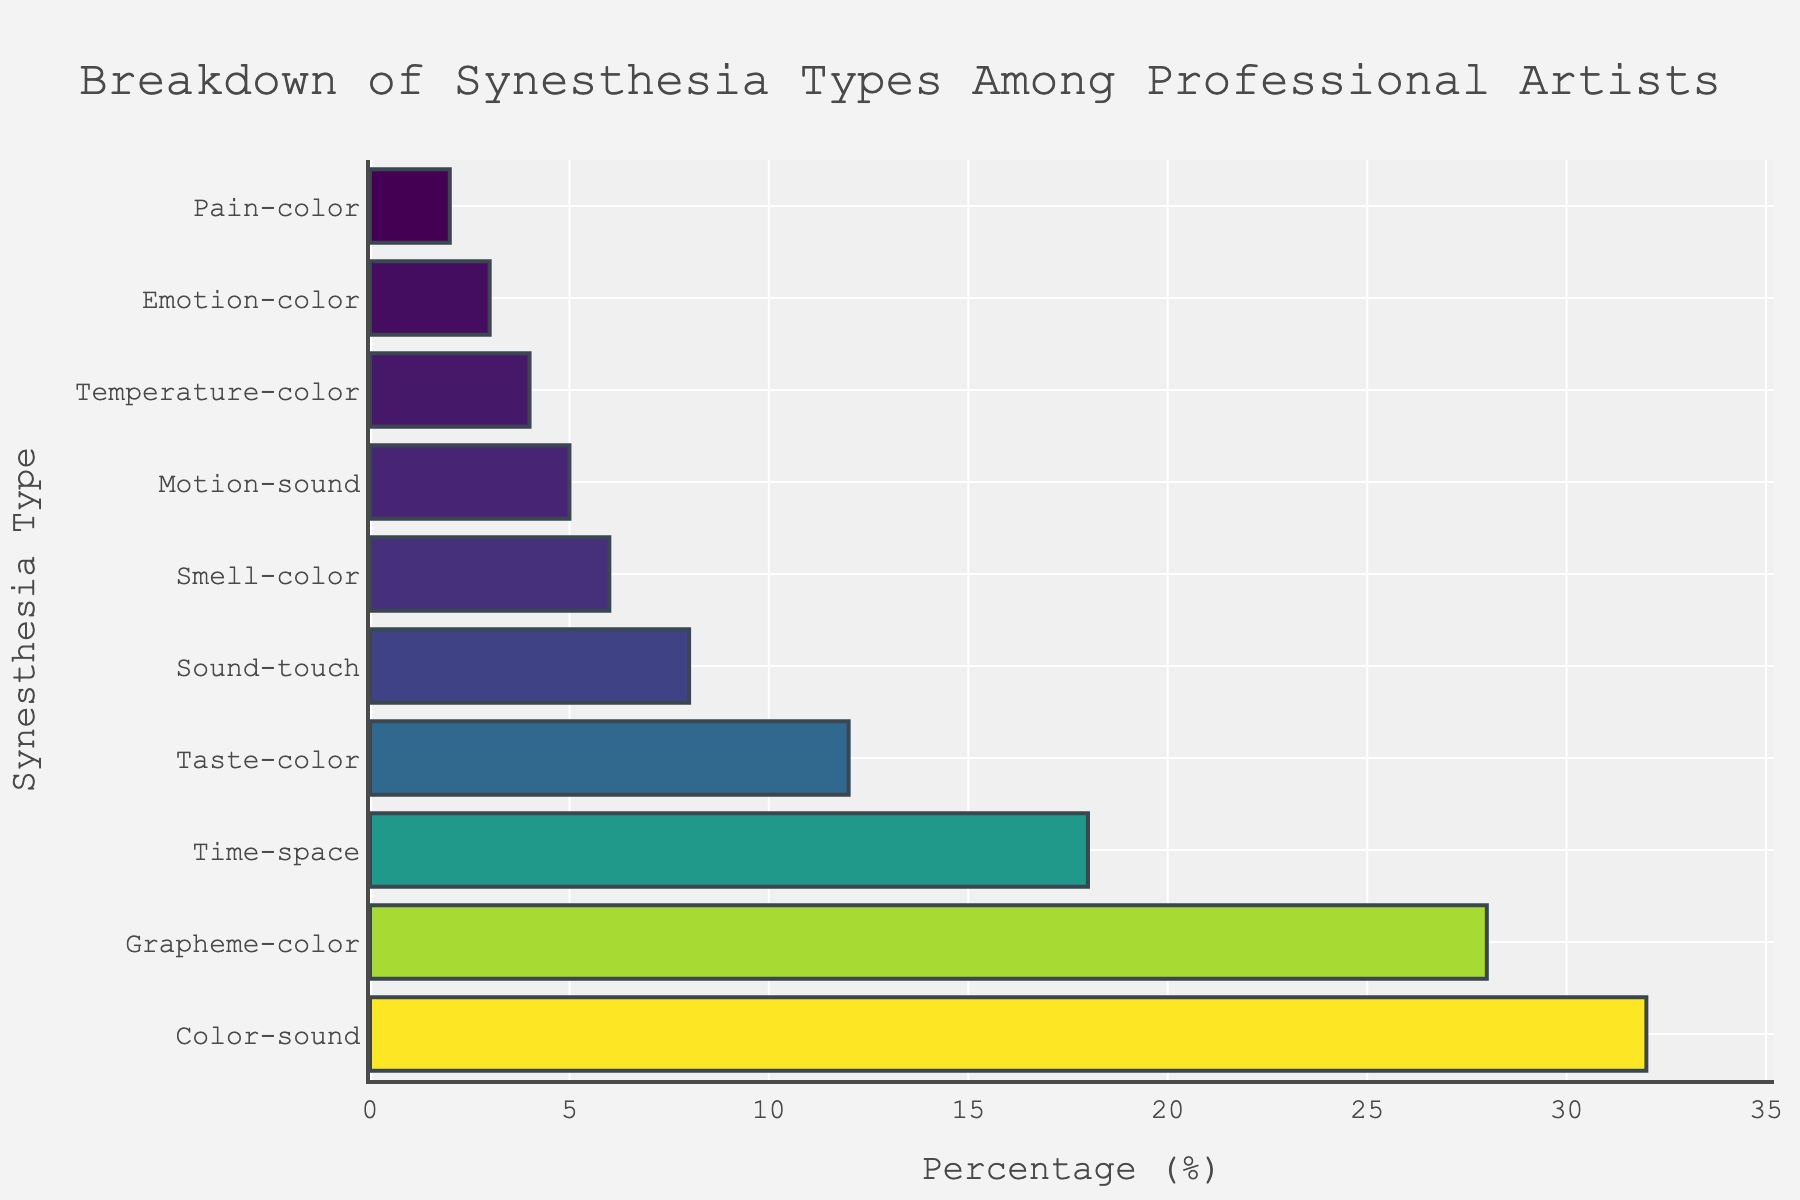what synesthesia types have a higher percentage than grapheme-color? Color-sound has a higher percentage than grapheme-color. The Color-sound bar is longer than the Grapheme-color bar, indicating a higher percentage (32% vs. 28%).
Answer: Color-sound Which synesthesia type has the lowest percentage? The Pain-color type has the lowest bar, indicating the lowest percentage.
Answer: Pain-color What's the sum of the percentages for taste-color and sound-touch? The Taste-color bar shows 12% and the Sound-touch bar shows 8%. Summing these percentages: 12 + 8 = 20%.
Answer: 20% Which synesthesia type has twice the percentage of another type? The Color-sound percentage (32%) is almost twice that of Time-space (18%). Visually, the Color-sound bar is roughly double the length of the Time-space bar.
Answer: Color-sound What's the difference between the highest and lowest percentages? The highest percentage is Color-sound (32%) and the lowest is Pain-color (2%). The difference is 32 - 2 = 30%.
Answer: 30% Which synesthesia type is most common among professional artists? The Color-sound type has the longest bar, indicating it is the most common at 32%.
Answer: Color-sound Arrange the synesthesia types in descending order of their percentages. The order of the bars from longest to shortest gives: Color-sound (32%), Grapheme-color (28%), Time-space (18%), Taste-color (12%), Sound-touch (8%), Smell-color (6%), Motion-sound (5%), Temperature-color (4%), Emotion-color (3%), Pain-color (2%).
Answer: Color-sound, Grapheme-color, Time-space, Taste-color, Sound-touch, Smell-color, Motion-sound, Temperature-color, Emotion-color, Pain-color How many synesthesia types have a percentage less than 10%? Counting the bars with lengths indicating less than 10%: Sound-touch (8%), Smell-color (6%), Motion-sound (5%), Temperature-color (4%), Emotion-color (3%), Pain-color (2%). There are six such types.
Answer: 6 Is the sum of the percentages for grapheme-color and time-space more than 45%? Grapheme-color is 28% and Time-space is 18%. Summing them: 28 + 18 = 46%, which is more than 45%.
Answer: Yes Which synesthesia types have a percentage that’s less than half of color-sound? Color-sound is 32%. Half of this is 16%. The synesthesia types with percentages less than 16% are Time-space (18%), Taste-color (12%), Sound-touch (8%), Smell-color (6%), Motion-sound (5%), Temperature-color (4%), Emotion-color (3%), and Pain-color (2%).
Answer: Time-space, Taste-color, Sound-touch, Smell-color, Motion-sound, Temperature-color, Emotion-color, Pain-color 